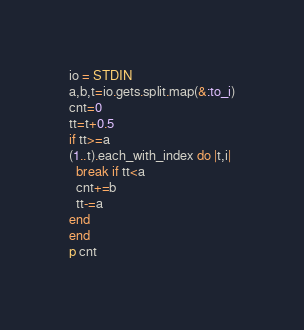Convert code to text. <code><loc_0><loc_0><loc_500><loc_500><_Ruby_>io = STDIN
a,b,t=io.gets.split.map(&:to_i)
cnt=0
tt=t+0.5
if tt>=a
(1..t).each_with_index do |t,i|
  break if tt<a
  cnt+=b
  tt-=a
end
end
p cnt
</code> 